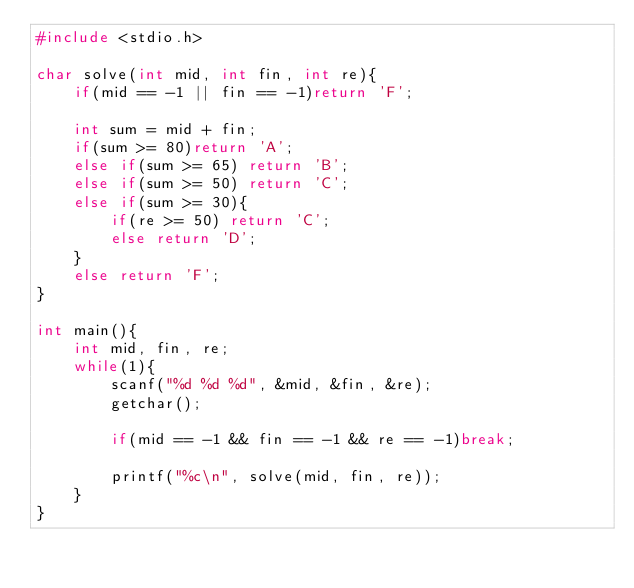<code> <loc_0><loc_0><loc_500><loc_500><_C_>#include <stdio.h>

char solve(int mid, int fin, int re){
    if(mid == -1 || fin == -1)return 'F';

    int sum = mid + fin;
    if(sum >= 80)return 'A';
    else if(sum >= 65) return 'B';
    else if(sum >= 50) return 'C';
    else if(sum >= 30){
        if(re >= 50) return 'C';
        else return 'D';
    }
    else return 'F';
}

int main(){
    int mid, fin, re;
    while(1){
        scanf("%d %d %d", &mid, &fin, &re);
        getchar();

        if(mid == -1 && fin == -1 && re == -1)break;

        printf("%c\n", solve(mid, fin, re));
    }
}
</code> 